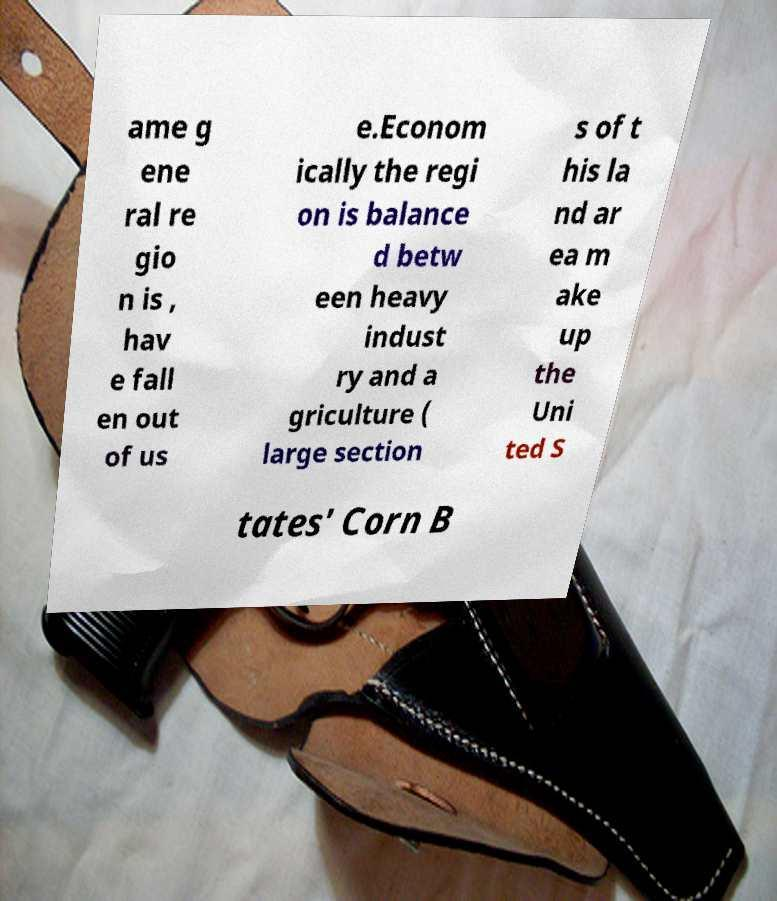Please identify and transcribe the text found in this image. ame g ene ral re gio n is , hav e fall en out of us e.Econom ically the regi on is balance d betw een heavy indust ry and a griculture ( large section s of t his la nd ar ea m ake up the Uni ted S tates' Corn B 